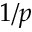<formula> <loc_0><loc_0><loc_500><loc_500>1 / p</formula> 